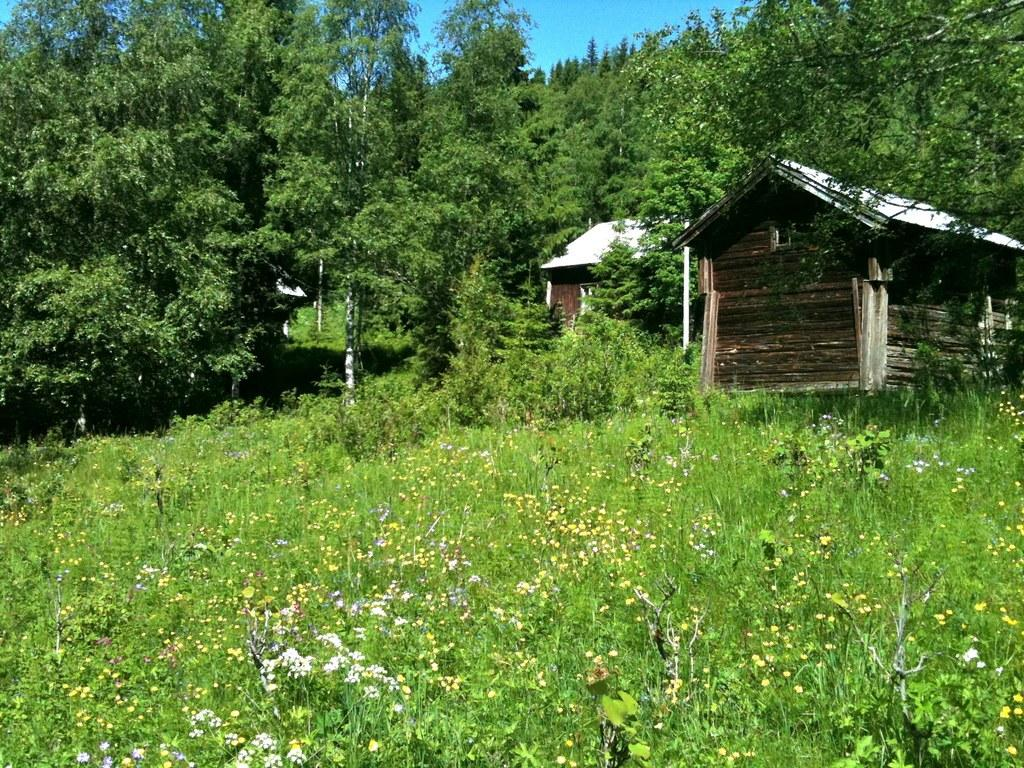What type of living organisms can be seen in the image? There are many plants with flowers in the image. What type of structures are present in the image? There are houses in the image, including one made of wood. What can be seen in the background of the image? There are trees and the sky visible in the background of the image. What type of map can be seen in the image? There is no map present in the image. Can you describe the truck that is parked near the houses in the image? There is no truck present in the image; only houses, plants, and trees are visible. 